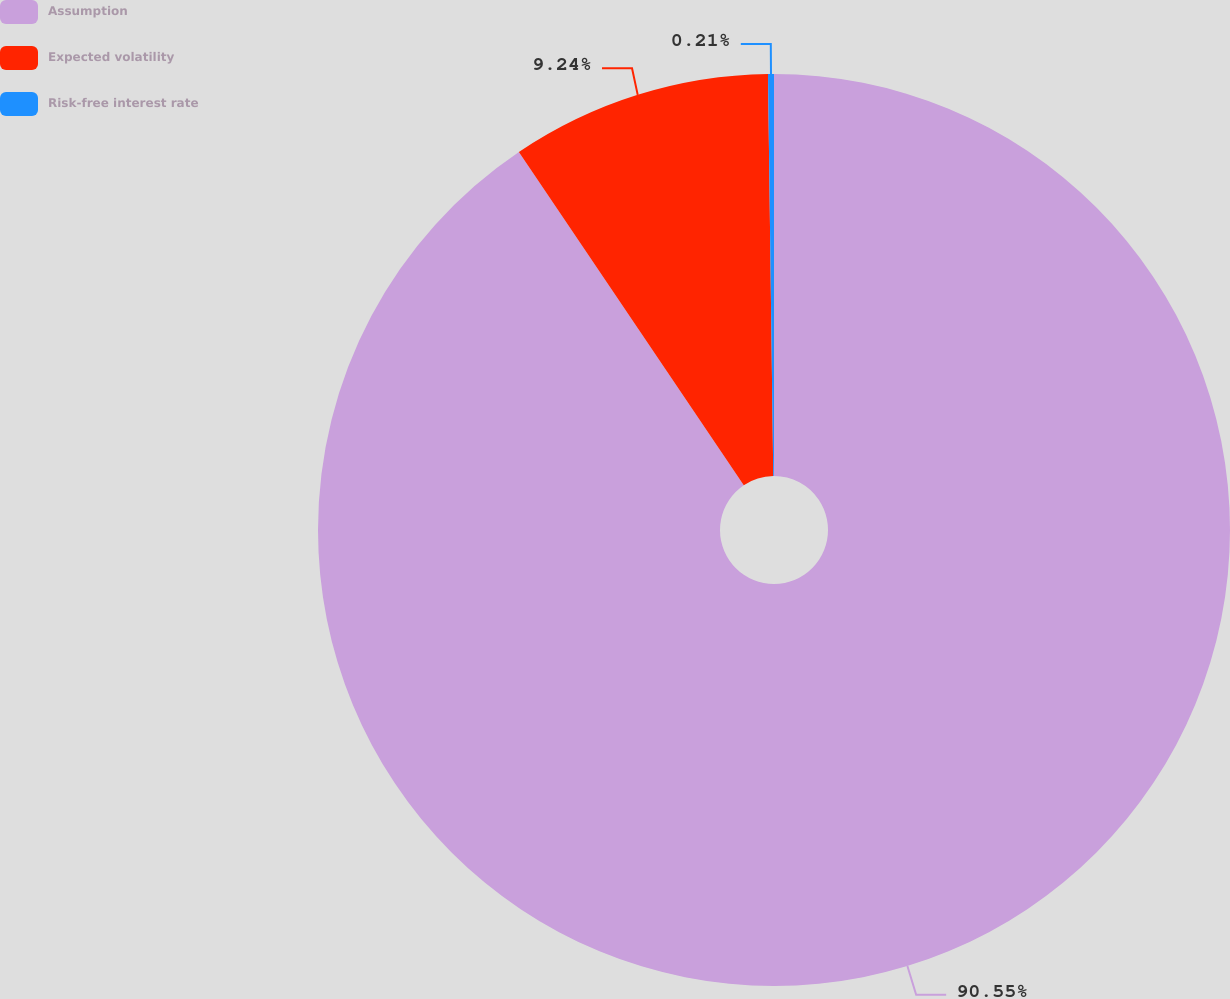Convert chart. <chart><loc_0><loc_0><loc_500><loc_500><pie_chart><fcel>Assumption<fcel>Expected volatility<fcel>Risk-free interest rate<nl><fcel>90.55%<fcel>9.24%<fcel>0.21%<nl></chart> 